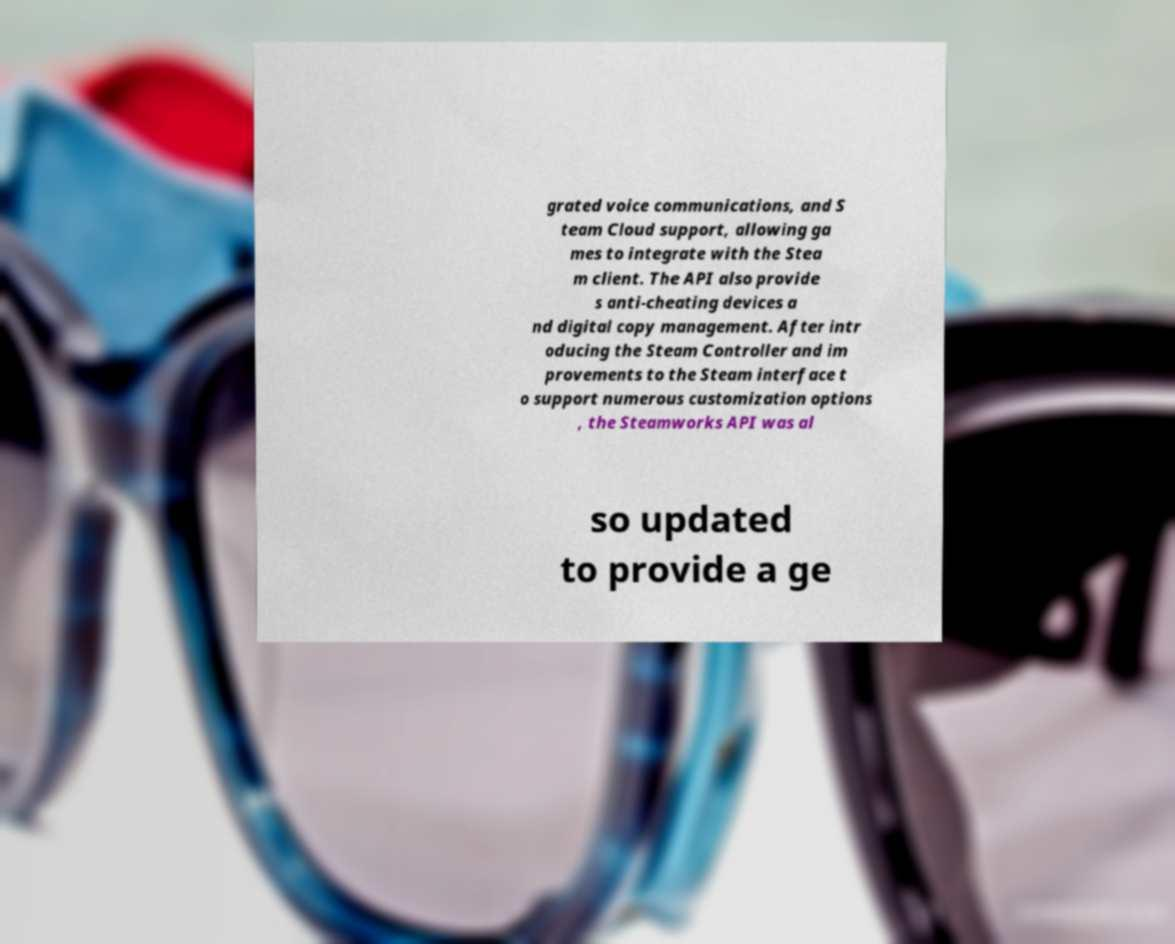There's text embedded in this image that I need extracted. Can you transcribe it verbatim? grated voice communications, and S team Cloud support, allowing ga mes to integrate with the Stea m client. The API also provide s anti-cheating devices a nd digital copy management. After intr oducing the Steam Controller and im provements to the Steam interface t o support numerous customization options , the Steamworks API was al so updated to provide a ge 